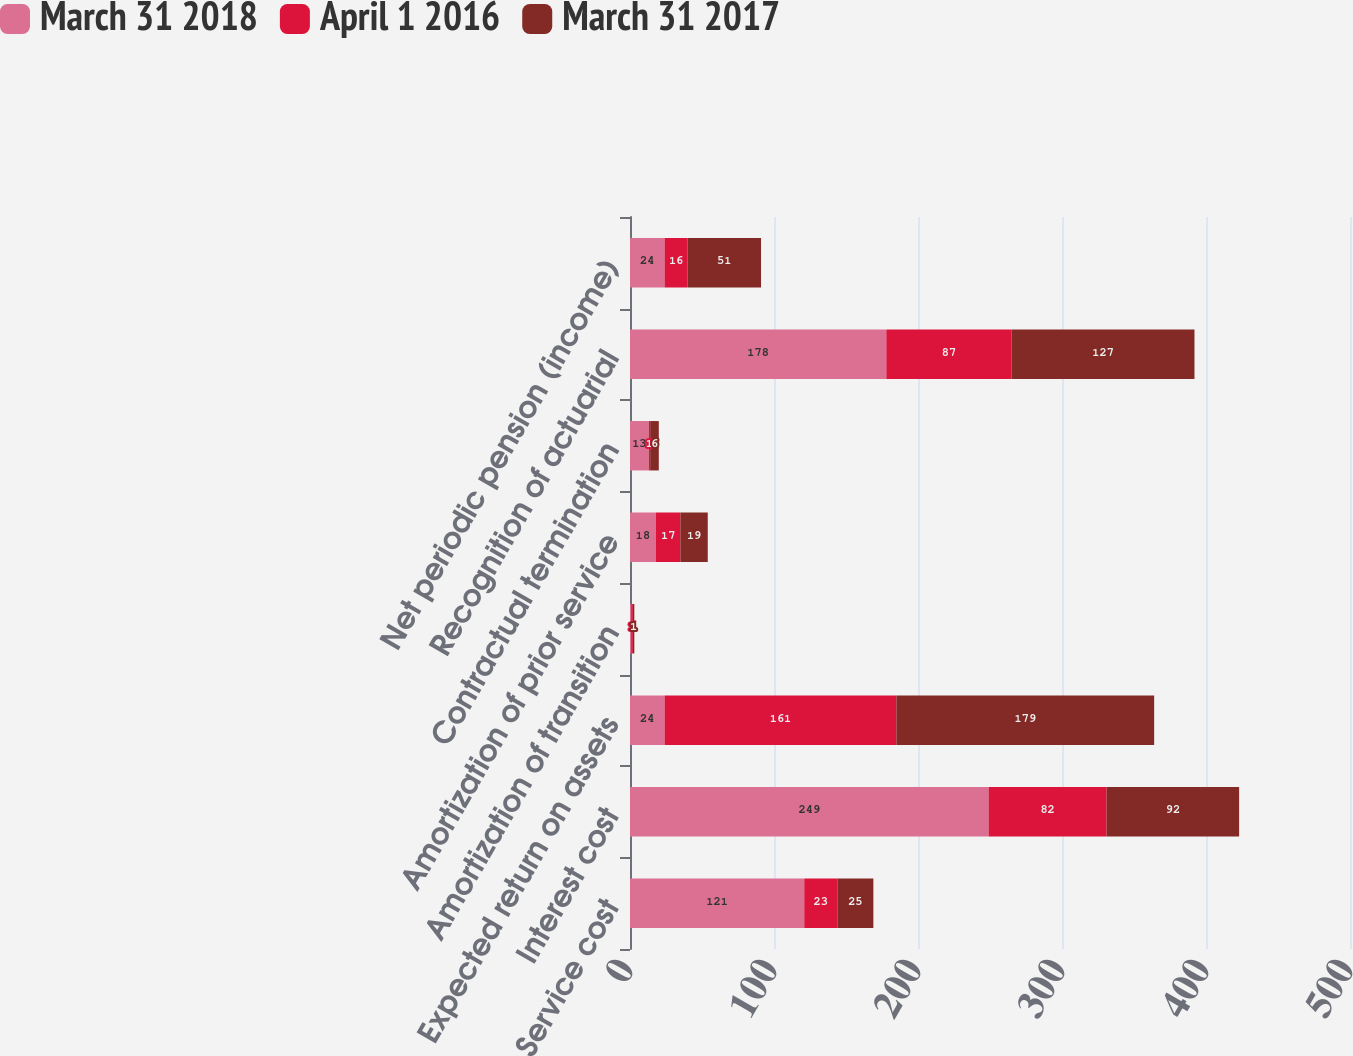<chart> <loc_0><loc_0><loc_500><loc_500><stacked_bar_chart><ecel><fcel>Service cost<fcel>Interest cost<fcel>Expected return on assets<fcel>Amortization of transition<fcel>Amortization of prior service<fcel>Contractual termination<fcel>Recognition of actuarial<fcel>Net periodic pension (income)<nl><fcel>March 31 2018<fcel>121<fcel>249<fcel>24<fcel>1<fcel>18<fcel>13<fcel>178<fcel>24<nl><fcel>April 1 2016<fcel>23<fcel>82<fcel>161<fcel>1<fcel>17<fcel>1<fcel>87<fcel>16<nl><fcel>March 31 2017<fcel>25<fcel>92<fcel>179<fcel>1<fcel>19<fcel>6<fcel>127<fcel>51<nl></chart> 